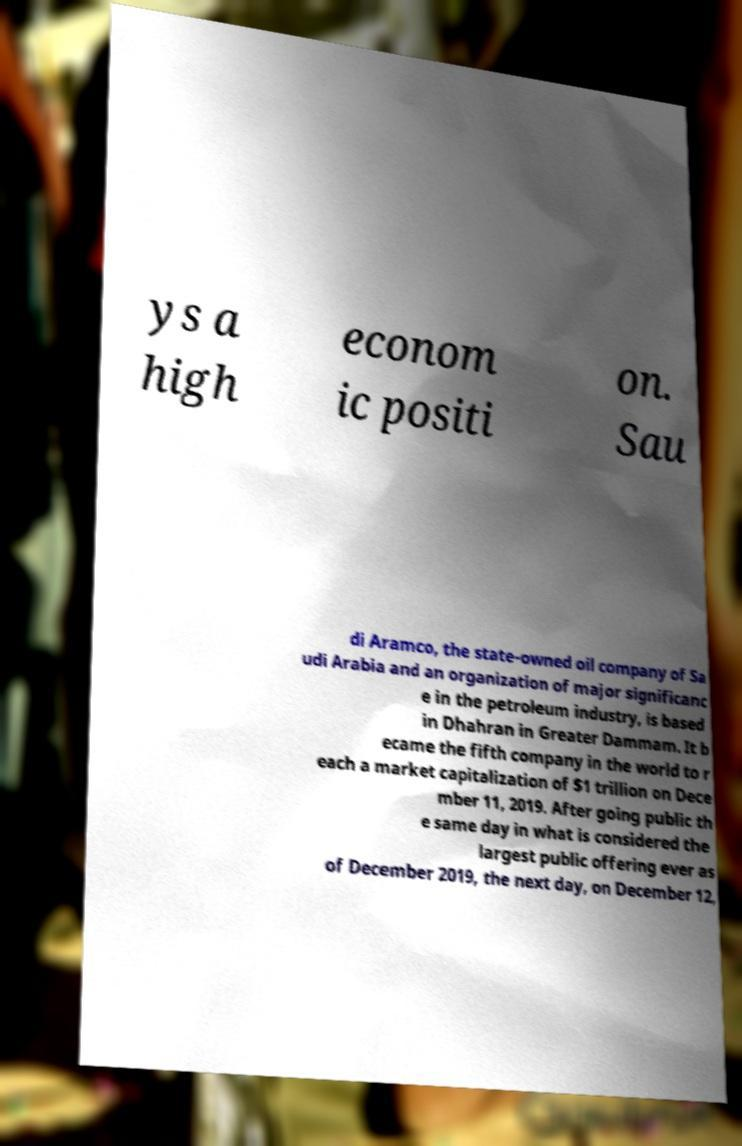Can you accurately transcribe the text from the provided image for me? ys a high econom ic positi on. Sau di Aramco, the state-owned oil company of Sa udi Arabia and an organization of major significanc e in the petroleum industry, is based in Dhahran in Greater Dammam. It b ecame the fifth company in the world to r each a market capitalization of $1 trillion on Dece mber 11, 2019. After going public th e same day in what is considered the largest public offering ever as of December 2019, the next day, on December 12, 